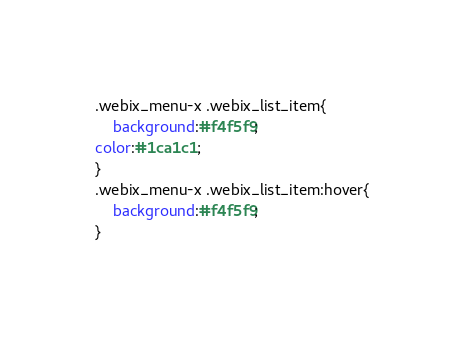Convert code to text. <code><loc_0><loc_0><loc_500><loc_500><_CSS_>.webix_menu-x .webix_list_item{
    background:#f4f5f9;
color:#1ca1c1;
}
.webix_menu-x .webix_list_item:hover{
    background:#f4f5f9;
}</code> 